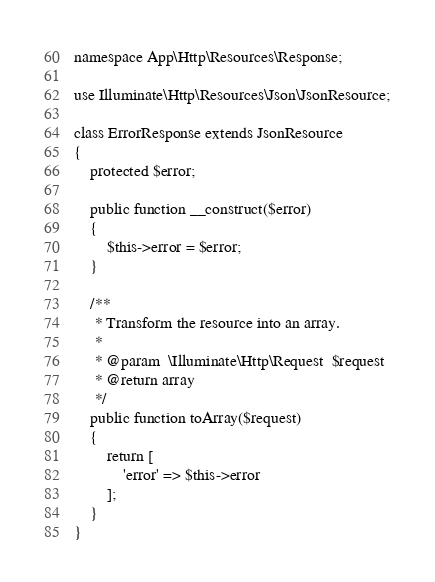<code> <loc_0><loc_0><loc_500><loc_500><_PHP_>
namespace App\Http\Resources\Response;

use Illuminate\Http\Resources\Json\JsonResource;

class ErrorResponse extends JsonResource
{
    protected $error;

    public function __construct($error)
    {
        $this->error = $error;
    }

    /**
     * Transform the resource into an array.
     *
     * @param  \Illuminate\Http\Request  $request
     * @return array
     */
    public function toArray($request)
    {
        return [
            'error' => $this->error
        ];
    }
}
</code> 